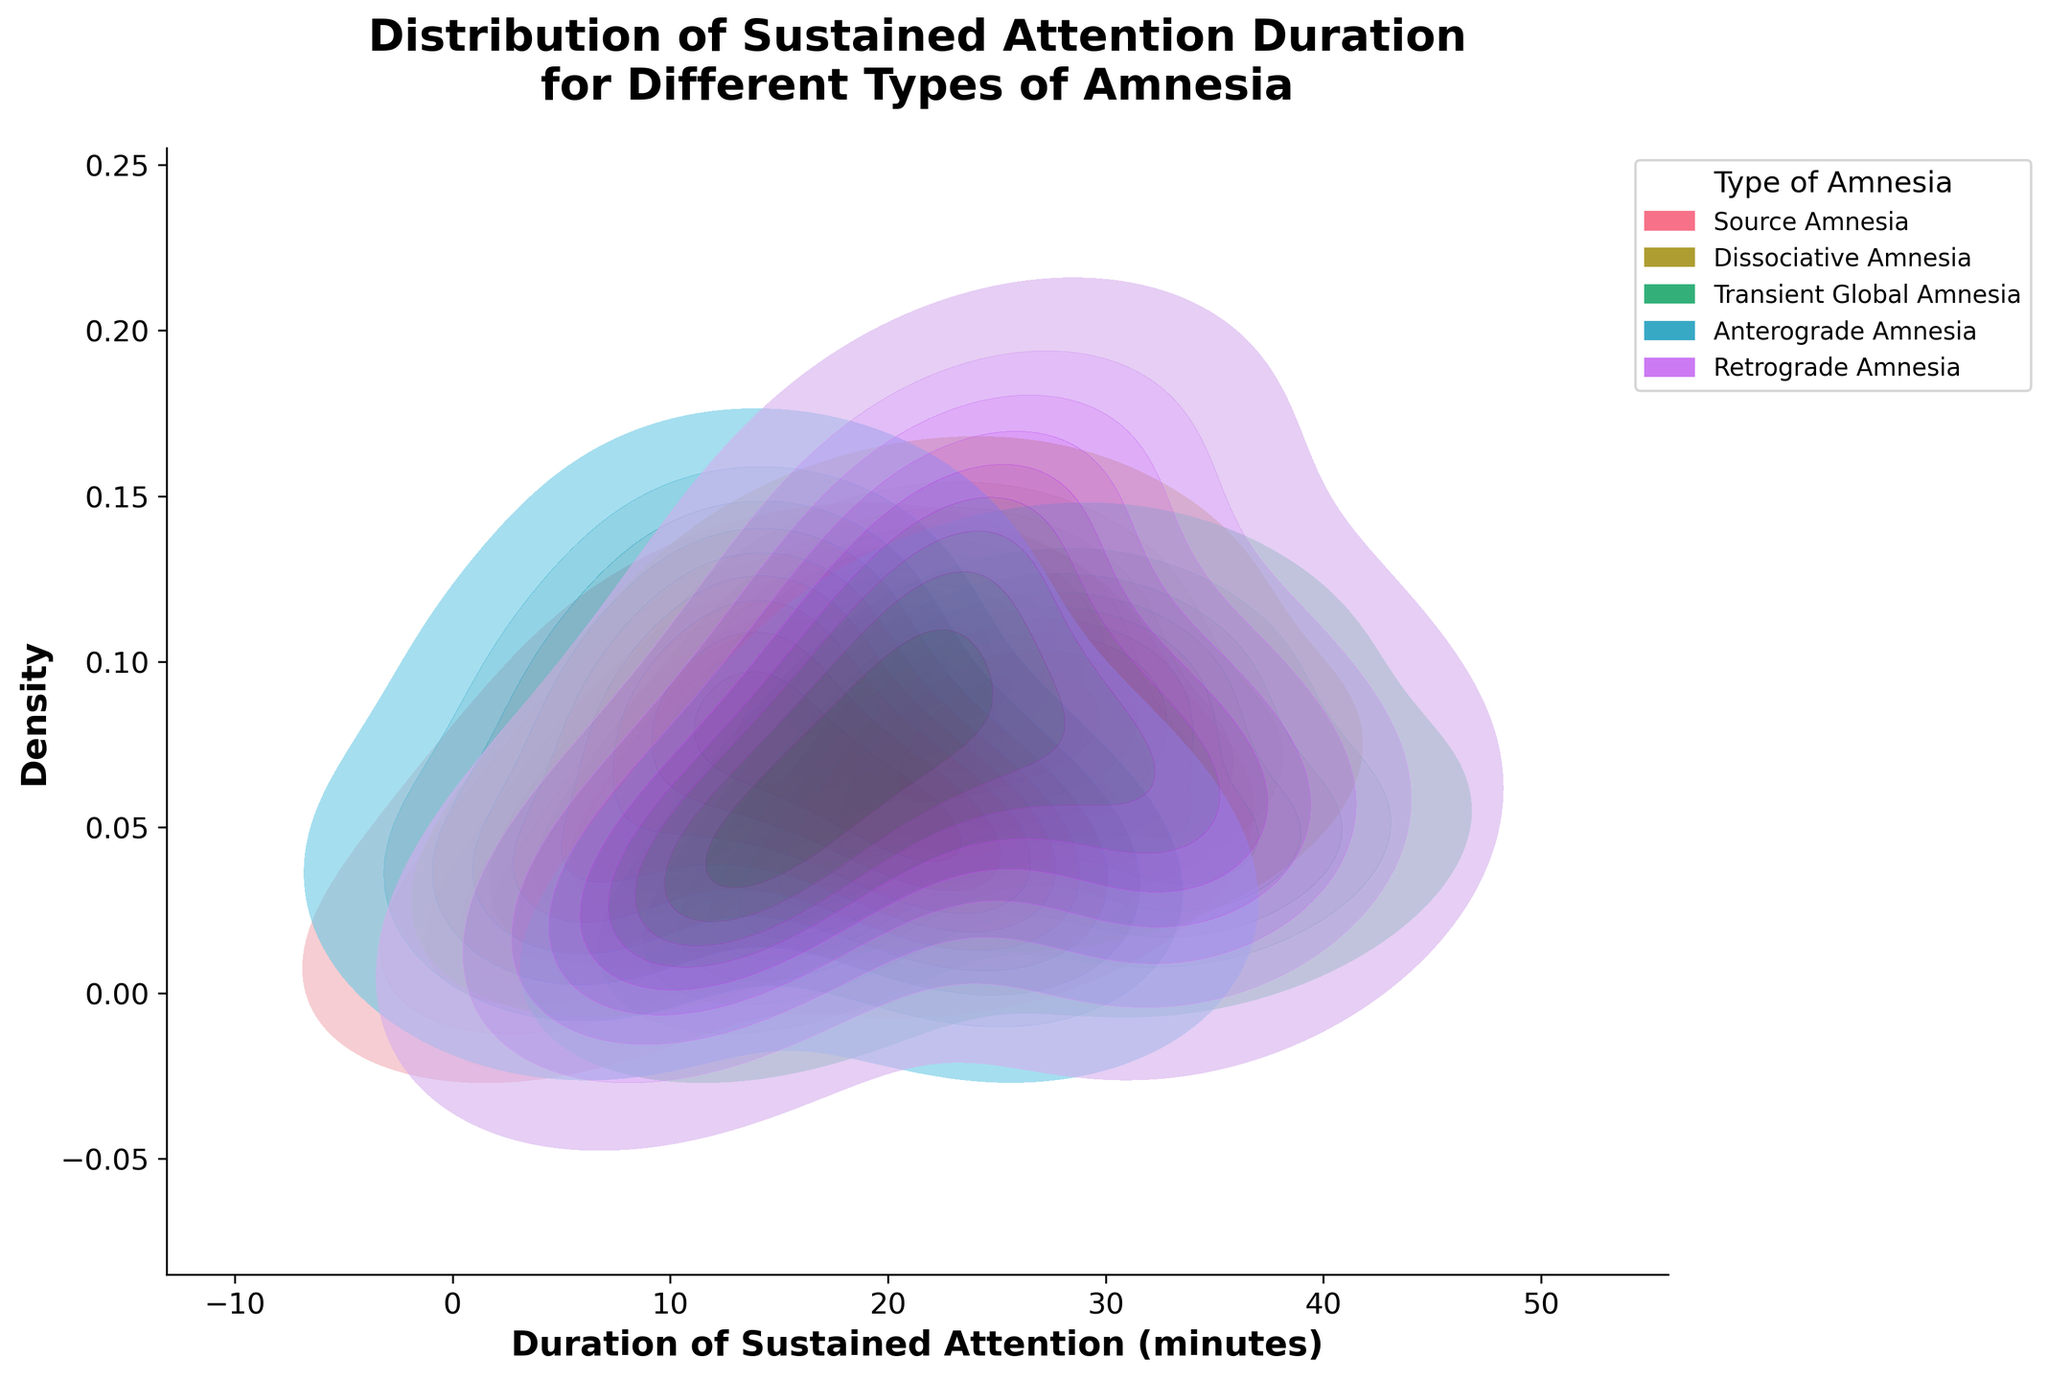What is the title of the plot? The title of the plot is located at the top and reads "Distribution of Sustained Attention Duration for Different Types of Amnesia".
Answer: Distribution of Sustained Attention Duration for Different Types of Amnesia What does the x-axis represent in this plot? The x-axis label is "Duration of Sustained Attention (minutes)", which indicates the duration of attention in minutes.
Answer: Duration of Sustained Attention (minutes) Which type of amnesia has the highest density peak? To determine the highest density peak, look for the color with the peak that reaches the highest value on the y-axis. The peak density is highest for Dissociative Amnesia.
Answer: Dissociative Amnesia How do the densities for Retrograde Amnesia and Anterograde Amnesia compare at a duration of 15 minutes? To compare the densities at 15 minutes, find the points on the density curves for both types at 15 minutes. Retrograde Amnesia has a density of 0.05, while Anterograde Amnesia has a density of 0.12, making Anterograde Amnesia higher.
Answer: Anterograde Amnesia is higher What is the approximate density value for Source Amnesia at 20 minutes? Locate the density value for Source Amnesia at the 20-minute mark; it is indicated by the Y-axis value where the curve intersects at 20 minutes. The density value is about 0.08.
Answer: 0.08 Which type of amnesia shows the most uniform distribution of sustained attention duration? By observing the density curves and comparing their shapes, the most uniform distribution is the one with less variation in densities. Transient Global Amnesia has a more spread out and less peaked distribution than others.
Answer: Transient Global Amnesia At what duration does Dissociative Amnesia reach its peak density, and what is that density? Look at the curve for Dissociative Amnesia and find the duration where it reaches its highest point. The peak occurs at 20 minutes with a density of 0.12.
Answer: 20 minutes, 0.12 How do the peaks of Source Amnesia and Transient Global Amnesia differ in terms of duration and density? Compare the peaks of the curves for Source Amnesia and Transient Global Amnesia. Source Amnesia peaks at 15 minutes with a density of 0.10, while Transient Global Amnesia peaks at 25 minutes with a density of 0.10 as well.
Answer: Source Amnesia peaks at 15 minutes with a density of 0.10, Transient Global Amnesia peaks at 25 minutes with a density of 0.10 What is the range of sustained attention duration for Retrograde Amnesia with notable densities? Notable densities are those where the density value is higher than the baseline. Retrograde Amnesia densities start becoming noticeable around 10 minutes and last until around 35 minutes.
Answer: 10 to 35 minutes 